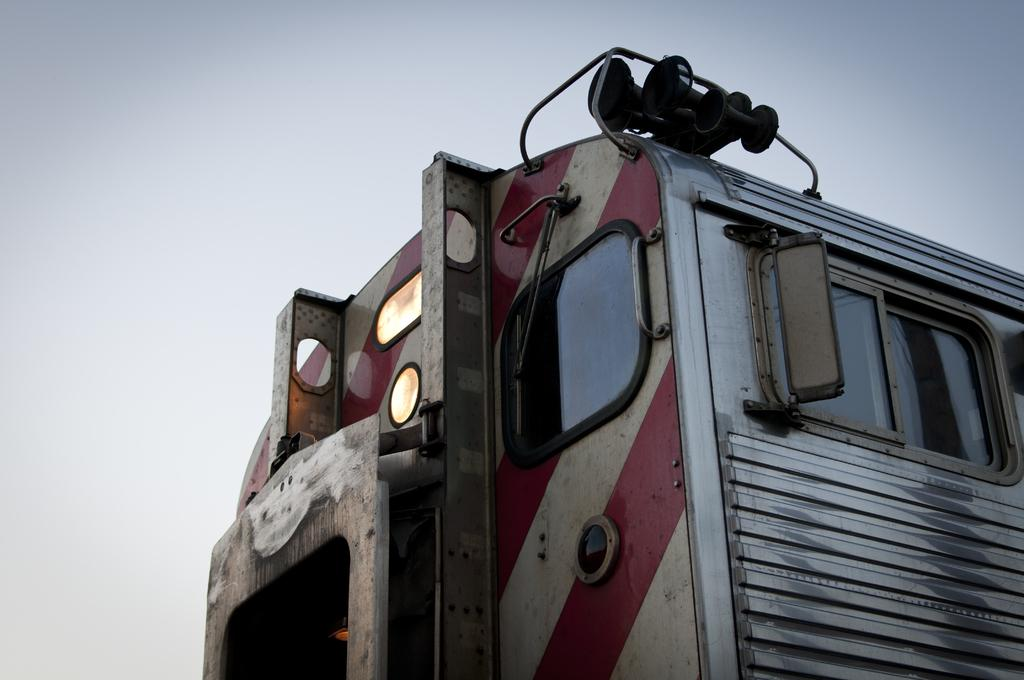What is the main subject of the image? The main subject of the image is a part of a train. What features can be seen on the train? The train has windows. What can be seen in the background of the image? The sky is visible in the background of the image. Is there a volcano erupting in the background of the image? No, there is no volcano present in the image. How can we tell if the train is traveling in a quiet environment? The image does not provide any information about the noise level around the train. 